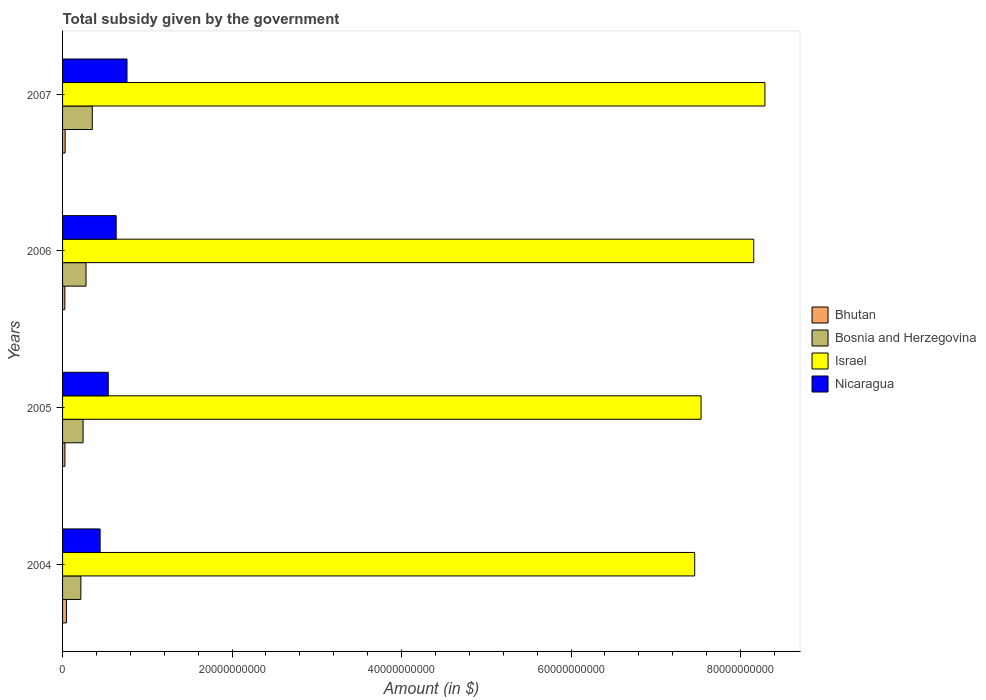How many different coloured bars are there?
Make the answer very short. 4. How many groups of bars are there?
Offer a very short reply. 4. How many bars are there on the 2nd tick from the top?
Provide a short and direct response. 4. How many bars are there on the 2nd tick from the bottom?
Ensure brevity in your answer.  4. In how many cases, is the number of bars for a given year not equal to the number of legend labels?
Your answer should be very brief. 0. What is the total revenue collected by the government in Bosnia and Herzegovina in 2004?
Make the answer very short. 2.16e+09. Across all years, what is the maximum total revenue collected by the government in Bosnia and Herzegovina?
Your response must be concise. 3.51e+09. Across all years, what is the minimum total revenue collected by the government in Nicaragua?
Your answer should be very brief. 4.43e+09. In which year was the total revenue collected by the government in Bhutan minimum?
Offer a terse response. 2006. What is the total total revenue collected by the government in Israel in the graph?
Your response must be concise. 3.14e+11. What is the difference between the total revenue collected by the government in Bosnia and Herzegovina in 2004 and that in 2006?
Provide a succinct answer. -6.09e+08. What is the difference between the total revenue collected by the government in Bhutan in 2006 and the total revenue collected by the government in Israel in 2007?
Provide a succinct answer. -8.26e+1. What is the average total revenue collected by the government in Bhutan per year?
Ensure brevity in your answer.  3.27e+08. In the year 2007, what is the difference between the total revenue collected by the government in Nicaragua and total revenue collected by the government in Bhutan?
Offer a terse response. 7.30e+09. What is the ratio of the total revenue collected by the government in Israel in 2005 to that in 2006?
Keep it short and to the point. 0.92. Is the total revenue collected by the government in Bhutan in 2005 less than that in 2006?
Offer a terse response. No. What is the difference between the highest and the second highest total revenue collected by the government in Nicaragua?
Offer a very short reply. 1.28e+09. What is the difference between the highest and the lowest total revenue collected by the government in Bosnia and Herzegovina?
Your response must be concise. 1.35e+09. In how many years, is the total revenue collected by the government in Israel greater than the average total revenue collected by the government in Israel taken over all years?
Your answer should be compact. 2. What does the 1st bar from the top in 2004 represents?
Provide a succinct answer. Nicaragua. How many bars are there?
Offer a terse response. 16. How many years are there in the graph?
Ensure brevity in your answer.  4. Where does the legend appear in the graph?
Your answer should be compact. Center right. How many legend labels are there?
Your answer should be very brief. 4. What is the title of the graph?
Your answer should be compact. Total subsidy given by the government. Does "Israel" appear as one of the legend labels in the graph?
Make the answer very short. Yes. What is the label or title of the X-axis?
Provide a short and direct response. Amount (in $). What is the label or title of the Y-axis?
Provide a succinct answer. Years. What is the Amount (in $) in Bhutan in 2004?
Keep it short and to the point. 4.56e+08. What is the Amount (in $) in Bosnia and Herzegovina in 2004?
Offer a very short reply. 2.16e+09. What is the Amount (in $) in Israel in 2004?
Ensure brevity in your answer.  7.46e+1. What is the Amount (in $) of Nicaragua in 2004?
Give a very brief answer. 4.43e+09. What is the Amount (in $) of Bhutan in 2005?
Give a very brief answer. 2.78e+08. What is the Amount (in $) of Bosnia and Herzegovina in 2005?
Ensure brevity in your answer.  2.42e+09. What is the Amount (in $) of Israel in 2005?
Offer a very short reply. 7.53e+1. What is the Amount (in $) in Nicaragua in 2005?
Your response must be concise. 5.39e+09. What is the Amount (in $) in Bhutan in 2006?
Your answer should be compact. 2.71e+08. What is the Amount (in $) of Bosnia and Herzegovina in 2006?
Your answer should be very brief. 2.77e+09. What is the Amount (in $) of Israel in 2006?
Give a very brief answer. 8.16e+1. What is the Amount (in $) of Nicaragua in 2006?
Provide a succinct answer. 6.33e+09. What is the Amount (in $) of Bhutan in 2007?
Keep it short and to the point. 3.05e+08. What is the Amount (in $) in Bosnia and Herzegovina in 2007?
Your answer should be compact. 3.51e+09. What is the Amount (in $) of Israel in 2007?
Offer a terse response. 8.29e+1. What is the Amount (in $) of Nicaragua in 2007?
Give a very brief answer. 7.60e+09. Across all years, what is the maximum Amount (in $) in Bhutan?
Make the answer very short. 4.56e+08. Across all years, what is the maximum Amount (in $) in Bosnia and Herzegovina?
Your answer should be very brief. 3.51e+09. Across all years, what is the maximum Amount (in $) of Israel?
Provide a succinct answer. 8.29e+1. Across all years, what is the maximum Amount (in $) in Nicaragua?
Provide a succinct answer. 7.60e+09. Across all years, what is the minimum Amount (in $) of Bhutan?
Give a very brief answer. 2.71e+08. Across all years, what is the minimum Amount (in $) of Bosnia and Herzegovina?
Your response must be concise. 2.16e+09. Across all years, what is the minimum Amount (in $) in Israel?
Offer a very short reply. 7.46e+1. Across all years, what is the minimum Amount (in $) of Nicaragua?
Your answer should be very brief. 4.43e+09. What is the total Amount (in $) of Bhutan in the graph?
Your response must be concise. 1.31e+09. What is the total Amount (in $) in Bosnia and Herzegovina in the graph?
Your answer should be compact. 1.09e+1. What is the total Amount (in $) of Israel in the graph?
Offer a very short reply. 3.14e+11. What is the total Amount (in $) of Nicaragua in the graph?
Keep it short and to the point. 2.37e+1. What is the difference between the Amount (in $) in Bhutan in 2004 and that in 2005?
Offer a very short reply. 1.77e+08. What is the difference between the Amount (in $) of Bosnia and Herzegovina in 2004 and that in 2005?
Your answer should be compact. -2.64e+08. What is the difference between the Amount (in $) in Israel in 2004 and that in 2005?
Offer a terse response. -7.47e+08. What is the difference between the Amount (in $) in Nicaragua in 2004 and that in 2005?
Provide a short and direct response. -9.60e+08. What is the difference between the Amount (in $) in Bhutan in 2004 and that in 2006?
Your answer should be compact. 1.85e+08. What is the difference between the Amount (in $) of Bosnia and Herzegovina in 2004 and that in 2006?
Your answer should be compact. -6.09e+08. What is the difference between the Amount (in $) in Israel in 2004 and that in 2006?
Offer a very short reply. -6.97e+09. What is the difference between the Amount (in $) in Nicaragua in 2004 and that in 2006?
Provide a succinct answer. -1.90e+09. What is the difference between the Amount (in $) of Bhutan in 2004 and that in 2007?
Your answer should be very brief. 1.51e+08. What is the difference between the Amount (in $) in Bosnia and Herzegovina in 2004 and that in 2007?
Give a very brief answer. -1.35e+09. What is the difference between the Amount (in $) in Israel in 2004 and that in 2007?
Make the answer very short. -8.28e+09. What is the difference between the Amount (in $) in Nicaragua in 2004 and that in 2007?
Keep it short and to the point. -3.17e+09. What is the difference between the Amount (in $) in Bhutan in 2005 and that in 2006?
Offer a very short reply. 7.73e+06. What is the difference between the Amount (in $) of Bosnia and Herzegovina in 2005 and that in 2006?
Ensure brevity in your answer.  -3.45e+08. What is the difference between the Amount (in $) of Israel in 2005 and that in 2006?
Make the answer very short. -6.22e+09. What is the difference between the Amount (in $) in Nicaragua in 2005 and that in 2006?
Ensure brevity in your answer.  -9.37e+08. What is the difference between the Amount (in $) of Bhutan in 2005 and that in 2007?
Your answer should be compact. -2.63e+07. What is the difference between the Amount (in $) in Bosnia and Herzegovina in 2005 and that in 2007?
Give a very brief answer. -1.09e+09. What is the difference between the Amount (in $) of Israel in 2005 and that in 2007?
Give a very brief answer. -7.54e+09. What is the difference between the Amount (in $) of Nicaragua in 2005 and that in 2007?
Keep it short and to the point. -2.21e+09. What is the difference between the Amount (in $) in Bhutan in 2006 and that in 2007?
Provide a succinct answer. -3.40e+07. What is the difference between the Amount (in $) of Bosnia and Herzegovina in 2006 and that in 2007?
Provide a short and direct response. -7.43e+08. What is the difference between the Amount (in $) in Israel in 2006 and that in 2007?
Keep it short and to the point. -1.32e+09. What is the difference between the Amount (in $) in Nicaragua in 2006 and that in 2007?
Make the answer very short. -1.28e+09. What is the difference between the Amount (in $) of Bhutan in 2004 and the Amount (in $) of Bosnia and Herzegovina in 2005?
Make the answer very short. -1.97e+09. What is the difference between the Amount (in $) in Bhutan in 2004 and the Amount (in $) in Israel in 2005?
Ensure brevity in your answer.  -7.49e+1. What is the difference between the Amount (in $) in Bhutan in 2004 and the Amount (in $) in Nicaragua in 2005?
Provide a succinct answer. -4.93e+09. What is the difference between the Amount (in $) of Bosnia and Herzegovina in 2004 and the Amount (in $) of Israel in 2005?
Your answer should be compact. -7.32e+1. What is the difference between the Amount (in $) of Bosnia and Herzegovina in 2004 and the Amount (in $) of Nicaragua in 2005?
Ensure brevity in your answer.  -3.23e+09. What is the difference between the Amount (in $) in Israel in 2004 and the Amount (in $) in Nicaragua in 2005?
Keep it short and to the point. 6.92e+1. What is the difference between the Amount (in $) of Bhutan in 2004 and the Amount (in $) of Bosnia and Herzegovina in 2006?
Provide a short and direct response. -2.31e+09. What is the difference between the Amount (in $) in Bhutan in 2004 and the Amount (in $) in Israel in 2006?
Ensure brevity in your answer.  -8.11e+1. What is the difference between the Amount (in $) in Bhutan in 2004 and the Amount (in $) in Nicaragua in 2006?
Offer a terse response. -5.87e+09. What is the difference between the Amount (in $) in Bosnia and Herzegovina in 2004 and the Amount (in $) in Israel in 2006?
Offer a terse response. -7.94e+1. What is the difference between the Amount (in $) of Bosnia and Herzegovina in 2004 and the Amount (in $) of Nicaragua in 2006?
Make the answer very short. -4.17e+09. What is the difference between the Amount (in $) in Israel in 2004 and the Amount (in $) in Nicaragua in 2006?
Your response must be concise. 6.83e+1. What is the difference between the Amount (in $) in Bhutan in 2004 and the Amount (in $) in Bosnia and Herzegovina in 2007?
Offer a very short reply. -3.05e+09. What is the difference between the Amount (in $) of Bhutan in 2004 and the Amount (in $) of Israel in 2007?
Ensure brevity in your answer.  -8.24e+1. What is the difference between the Amount (in $) of Bhutan in 2004 and the Amount (in $) of Nicaragua in 2007?
Your answer should be compact. -7.15e+09. What is the difference between the Amount (in $) of Bosnia and Herzegovina in 2004 and the Amount (in $) of Israel in 2007?
Make the answer very short. -8.07e+1. What is the difference between the Amount (in $) in Bosnia and Herzegovina in 2004 and the Amount (in $) in Nicaragua in 2007?
Offer a terse response. -5.45e+09. What is the difference between the Amount (in $) in Israel in 2004 and the Amount (in $) in Nicaragua in 2007?
Offer a very short reply. 6.70e+1. What is the difference between the Amount (in $) of Bhutan in 2005 and the Amount (in $) of Bosnia and Herzegovina in 2006?
Keep it short and to the point. -2.49e+09. What is the difference between the Amount (in $) in Bhutan in 2005 and the Amount (in $) in Israel in 2006?
Give a very brief answer. -8.13e+1. What is the difference between the Amount (in $) of Bhutan in 2005 and the Amount (in $) of Nicaragua in 2006?
Your answer should be compact. -6.05e+09. What is the difference between the Amount (in $) in Bosnia and Herzegovina in 2005 and the Amount (in $) in Israel in 2006?
Ensure brevity in your answer.  -7.91e+1. What is the difference between the Amount (in $) of Bosnia and Herzegovina in 2005 and the Amount (in $) of Nicaragua in 2006?
Give a very brief answer. -3.90e+09. What is the difference between the Amount (in $) of Israel in 2005 and the Amount (in $) of Nicaragua in 2006?
Keep it short and to the point. 6.90e+1. What is the difference between the Amount (in $) in Bhutan in 2005 and the Amount (in $) in Bosnia and Herzegovina in 2007?
Offer a terse response. -3.23e+09. What is the difference between the Amount (in $) in Bhutan in 2005 and the Amount (in $) in Israel in 2007?
Your response must be concise. -8.26e+1. What is the difference between the Amount (in $) of Bhutan in 2005 and the Amount (in $) of Nicaragua in 2007?
Keep it short and to the point. -7.33e+09. What is the difference between the Amount (in $) in Bosnia and Herzegovina in 2005 and the Amount (in $) in Israel in 2007?
Make the answer very short. -8.05e+1. What is the difference between the Amount (in $) of Bosnia and Herzegovina in 2005 and the Amount (in $) of Nicaragua in 2007?
Keep it short and to the point. -5.18e+09. What is the difference between the Amount (in $) of Israel in 2005 and the Amount (in $) of Nicaragua in 2007?
Ensure brevity in your answer.  6.77e+1. What is the difference between the Amount (in $) in Bhutan in 2006 and the Amount (in $) in Bosnia and Herzegovina in 2007?
Provide a short and direct response. -3.24e+09. What is the difference between the Amount (in $) of Bhutan in 2006 and the Amount (in $) of Israel in 2007?
Offer a terse response. -8.26e+1. What is the difference between the Amount (in $) of Bhutan in 2006 and the Amount (in $) of Nicaragua in 2007?
Offer a very short reply. -7.33e+09. What is the difference between the Amount (in $) in Bosnia and Herzegovina in 2006 and the Amount (in $) in Israel in 2007?
Offer a terse response. -8.01e+1. What is the difference between the Amount (in $) of Bosnia and Herzegovina in 2006 and the Amount (in $) of Nicaragua in 2007?
Offer a very short reply. -4.84e+09. What is the difference between the Amount (in $) of Israel in 2006 and the Amount (in $) of Nicaragua in 2007?
Keep it short and to the point. 7.40e+1. What is the average Amount (in $) of Bhutan per year?
Offer a terse response. 3.27e+08. What is the average Amount (in $) in Bosnia and Herzegovina per year?
Your answer should be compact. 2.71e+09. What is the average Amount (in $) of Israel per year?
Your answer should be very brief. 7.86e+1. What is the average Amount (in $) of Nicaragua per year?
Ensure brevity in your answer.  5.94e+09. In the year 2004, what is the difference between the Amount (in $) of Bhutan and Amount (in $) of Bosnia and Herzegovina?
Your answer should be very brief. -1.70e+09. In the year 2004, what is the difference between the Amount (in $) of Bhutan and Amount (in $) of Israel?
Your response must be concise. -7.41e+1. In the year 2004, what is the difference between the Amount (in $) in Bhutan and Amount (in $) in Nicaragua?
Provide a succinct answer. -3.97e+09. In the year 2004, what is the difference between the Amount (in $) of Bosnia and Herzegovina and Amount (in $) of Israel?
Ensure brevity in your answer.  -7.24e+1. In the year 2004, what is the difference between the Amount (in $) of Bosnia and Herzegovina and Amount (in $) of Nicaragua?
Your answer should be very brief. -2.27e+09. In the year 2004, what is the difference between the Amount (in $) in Israel and Amount (in $) in Nicaragua?
Keep it short and to the point. 7.02e+1. In the year 2005, what is the difference between the Amount (in $) of Bhutan and Amount (in $) of Bosnia and Herzegovina?
Your answer should be very brief. -2.14e+09. In the year 2005, what is the difference between the Amount (in $) of Bhutan and Amount (in $) of Israel?
Make the answer very short. -7.51e+1. In the year 2005, what is the difference between the Amount (in $) in Bhutan and Amount (in $) in Nicaragua?
Ensure brevity in your answer.  -5.11e+09. In the year 2005, what is the difference between the Amount (in $) in Bosnia and Herzegovina and Amount (in $) in Israel?
Your answer should be very brief. -7.29e+1. In the year 2005, what is the difference between the Amount (in $) of Bosnia and Herzegovina and Amount (in $) of Nicaragua?
Keep it short and to the point. -2.97e+09. In the year 2005, what is the difference between the Amount (in $) in Israel and Amount (in $) in Nicaragua?
Your answer should be compact. 6.99e+1. In the year 2006, what is the difference between the Amount (in $) of Bhutan and Amount (in $) of Bosnia and Herzegovina?
Make the answer very short. -2.50e+09. In the year 2006, what is the difference between the Amount (in $) in Bhutan and Amount (in $) in Israel?
Keep it short and to the point. -8.13e+1. In the year 2006, what is the difference between the Amount (in $) in Bhutan and Amount (in $) in Nicaragua?
Your answer should be compact. -6.06e+09. In the year 2006, what is the difference between the Amount (in $) of Bosnia and Herzegovina and Amount (in $) of Israel?
Offer a very short reply. -7.88e+1. In the year 2006, what is the difference between the Amount (in $) in Bosnia and Herzegovina and Amount (in $) in Nicaragua?
Your answer should be very brief. -3.56e+09. In the year 2006, what is the difference between the Amount (in $) of Israel and Amount (in $) of Nicaragua?
Your answer should be very brief. 7.52e+1. In the year 2007, what is the difference between the Amount (in $) in Bhutan and Amount (in $) in Bosnia and Herzegovina?
Your answer should be compact. -3.20e+09. In the year 2007, what is the difference between the Amount (in $) in Bhutan and Amount (in $) in Israel?
Keep it short and to the point. -8.26e+1. In the year 2007, what is the difference between the Amount (in $) in Bhutan and Amount (in $) in Nicaragua?
Your response must be concise. -7.30e+09. In the year 2007, what is the difference between the Amount (in $) of Bosnia and Herzegovina and Amount (in $) of Israel?
Ensure brevity in your answer.  -7.94e+1. In the year 2007, what is the difference between the Amount (in $) in Bosnia and Herzegovina and Amount (in $) in Nicaragua?
Ensure brevity in your answer.  -4.09e+09. In the year 2007, what is the difference between the Amount (in $) in Israel and Amount (in $) in Nicaragua?
Offer a terse response. 7.53e+1. What is the ratio of the Amount (in $) of Bhutan in 2004 to that in 2005?
Your response must be concise. 1.64. What is the ratio of the Amount (in $) in Bosnia and Herzegovina in 2004 to that in 2005?
Offer a terse response. 0.89. What is the ratio of the Amount (in $) of Israel in 2004 to that in 2005?
Keep it short and to the point. 0.99. What is the ratio of the Amount (in $) of Nicaragua in 2004 to that in 2005?
Your answer should be compact. 0.82. What is the ratio of the Amount (in $) in Bhutan in 2004 to that in 2006?
Ensure brevity in your answer.  1.68. What is the ratio of the Amount (in $) of Bosnia and Herzegovina in 2004 to that in 2006?
Ensure brevity in your answer.  0.78. What is the ratio of the Amount (in $) in Israel in 2004 to that in 2006?
Keep it short and to the point. 0.91. What is the ratio of the Amount (in $) in Nicaragua in 2004 to that in 2006?
Make the answer very short. 0.7. What is the ratio of the Amount (in $) of Bhutan in 2004 to that in 2007?
Offer a terse response. 1.5. What is the ratio of the Amount (in $) of Bosnia and Herzegovina in 2004 to that in 2007?
Your answer should be compact. 0.61. What is the ratio of the Amount (in $) of Israel in 2004 to that in 2007?
Your answer should be compact. 0.9. What is the ratio of the Amount (in $) in Nicaragua in 2004 to that in 2007?
Keep it short and to the point. 0.58. What is the ratio of the Amount (in $) of Bhutan in 2005 to that in 2006?
Provide a succinct answer. 1.03. What is the ratio of the Amount (in $) of Bosnia and Herzegovina in 2005 to that in 2006?
Provide a short and direct response. 0.88. What is the ratio of the Amount (in $) of Israel in 2005 to that in 2006?
Keep it short and to the point. 0.92. What is the ratio of the Amount (in $) in Nicaragua in 2005 to that in 2006?
Keep it short and to the point. 0.85. What is the ratio of the Amount (in $) of Bhutan in 2005 to that in 2007?
Your response must be concise. 0.91. What is the ratio of the Amount (in $) of Bosnia and Herzegovina in 2005 to that in 2007?
Offer a terse response. 0.69. What is the ratio of the Amount (in $) in Israel in 2005 to that in 2007?
Your answer should be very brief. 0.91. What is the ratio of the Amount (in $) in Nicaragua in 2005 to that in 2007?
Your answer should be compact. 0.71. What is the ratio of the Amount (in $) in Bhutan in 2006 to that in 2007?
Provide a short and direct response. 0.89. What is the ratio of the Amount (in $) in Bosnia and Herzegovina in 2006 to that in 2007?
Provide a succinct answer. 0.79. What is the ratio of the Amount (in $) in Israel in 2006 to that in 2007?
Your answer should be compact. 0.98. What is the ratio of the Amount (in $) of Nicaragua in 2006 to that in 2007?
Your answer should be very brief. 0.83. What is the difference between the highest and the second highest Amount (in $) of Bhutan?
Keep it short and to the point. 1.51e+08. What is the difference between the highest and the second highest Amount (in $) in Bosnia and Herzegovina?
Your answer should be very brief. 7.43e+08. What is the difference between the highest and the second highest Amount (in $) of Israel?
Your answer should be compact. 1.32e+09. What is the difference between the highest and the second highest Amount (in $) in Nicaragua?
Keep it short and to the point. 1.28e+09. What is the difference between the highest and the lowest Amount (in $) of Bhutan?
Ensure brevity in your answer.  1.85e+08. What is the difference between the highest and the lowest Amount (in $) of Bosnia and Herzegovina?
Provide a succinct answer. 1.35e+09. What is the difference between the highest and the lowest Amount (in $) in Israel?
Offer a terse response. 8.28e+09. What is the difference between the highest and the lowest Amount (in $) in Nicaragua?
Keep it short and to the point. 3.17e+09. 